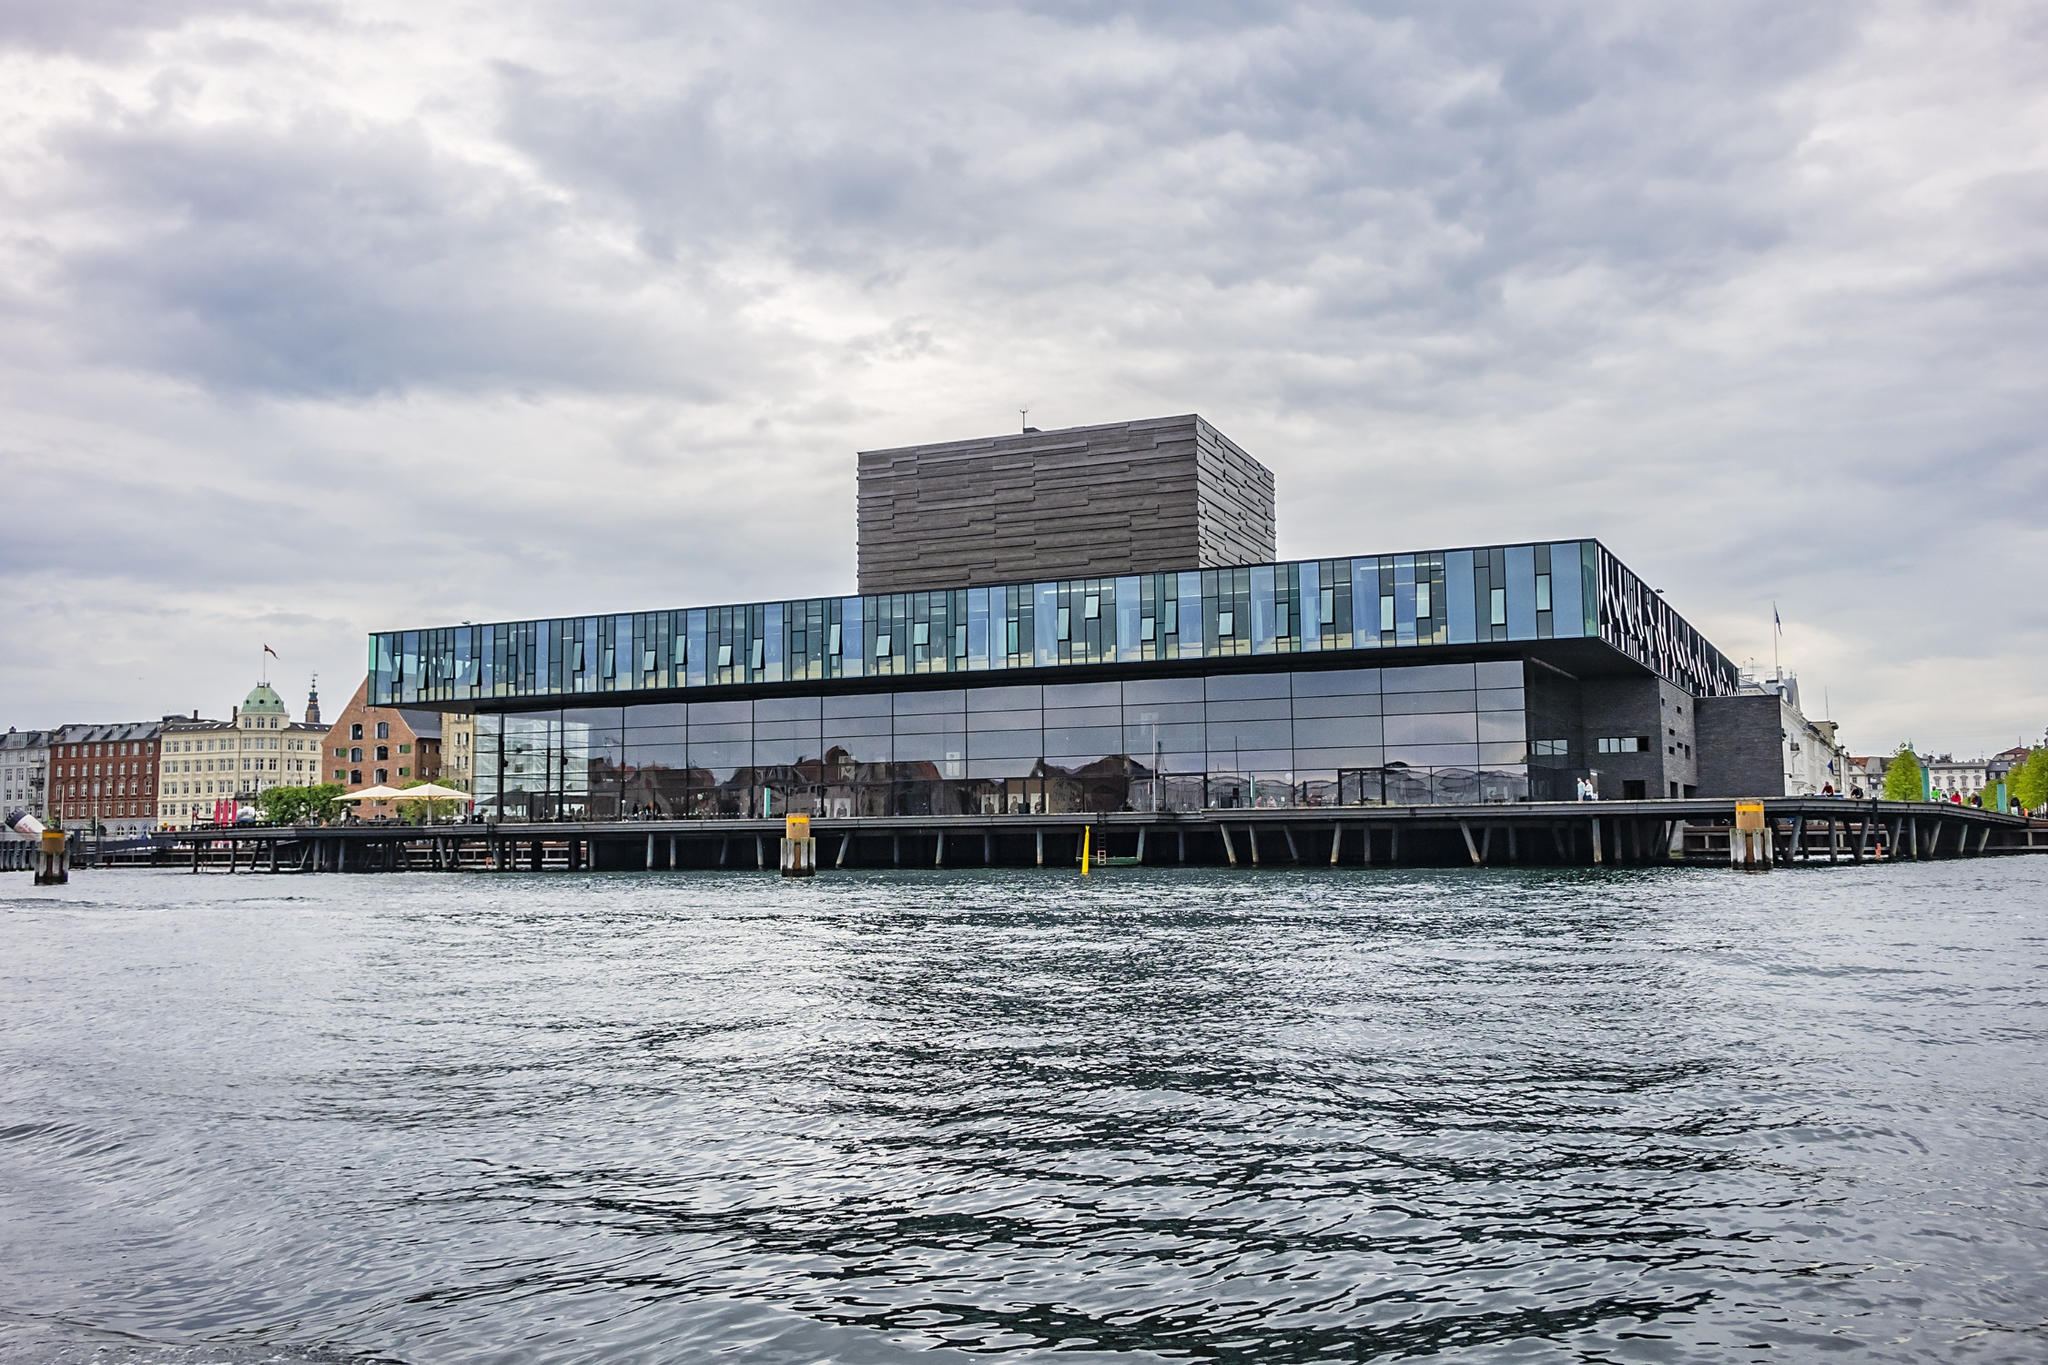Can you elaborate on the elements of the picture provided? The image showcases the Royal Danish Playhouse, a renowned landmark located on the waterfront in Copenhagen, Denmark. The building is a large, rectangular structure with a dark gray exterior that contrasts with the glass facade, reflecting the surrounding environment. It's situated on a pier, surrounded by the dark blue water that adds a serene atmosphere to the scene. The photo captures the building from a distance, placing it in the center of the frame, giving a comprehensive view of its modern architecture. The sky above is filled with clouds, adding a dramatic touch to the overall composition. The identifier "sa_17618" could possibly be a reference to the image or the specific viewpoint from which the photo was taken. The image does not contain any imaginary content; it's a straightforward, yet captivating representation of the Royal Danish Playhouse. 